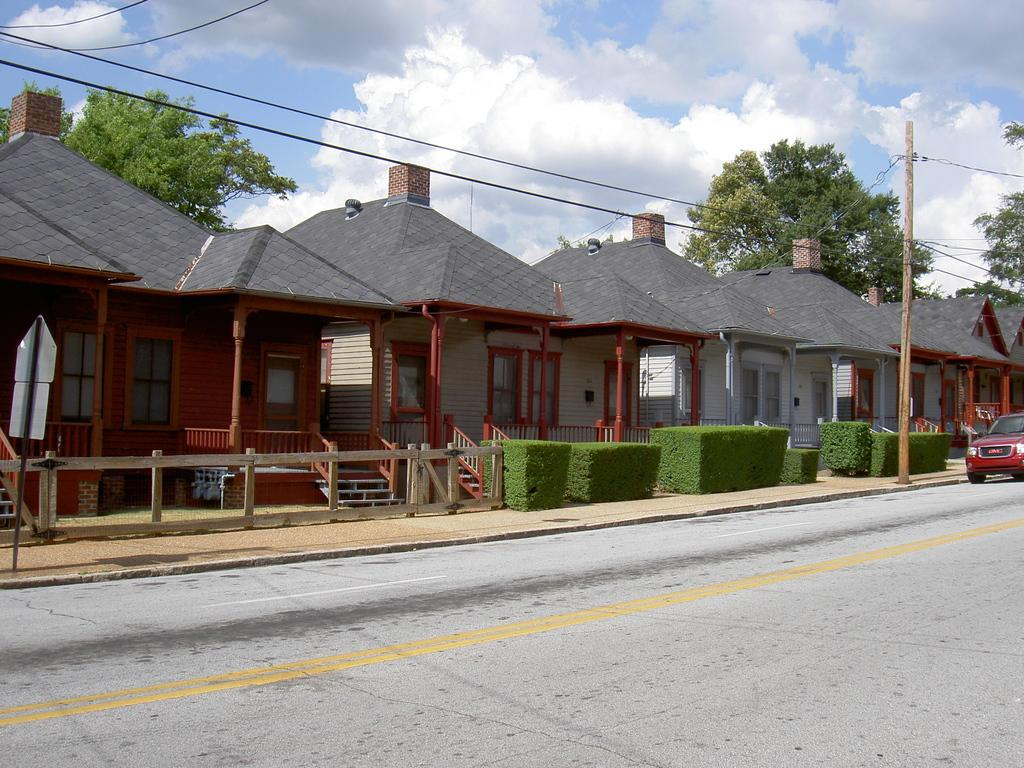What type of structures can be seen in the image? There are houses in the image. What is located in front of the houses? Shrubs are present in front of the houses. What else can be seen in the image besides the houses and shrubs? There are cables visible in the image, as well as a pole. Is there any transportation visible in the image? Yes, there is a car on the road in the image. What can be seen in the background of the image? Trees and clouds are visible in the background of the image. Can you tell me how many flowers are in the cellar of the house in the image? There is no information about flowers or a cellar in the image, so it is not possible to answer that question. 